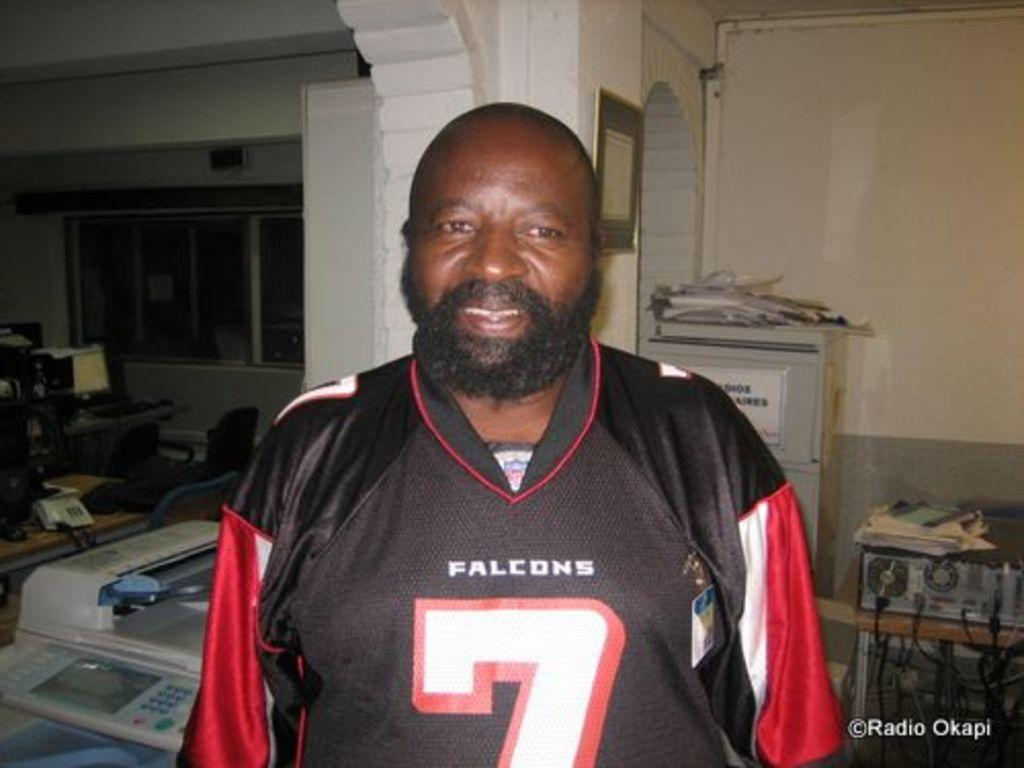<image>
Give a short and clear explanation of the subsequent image. A man in a jersey with the digit 7 on the front. 